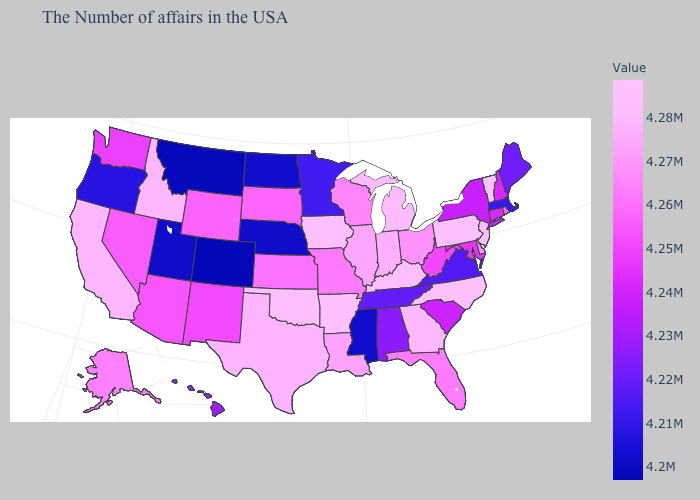Does Arizona have a lower value than Louisiana?
Be succinct. Yes. Does Arizona have a higher value than Alabama?
Keep it brief. Yes. Among the states that border Idaho , does Wyoming have the highest value?
Short answer required. Yes. Which states hav the highest value in the MidWest?
Short answer required. Iowa. Which states have the lowest value in the USA?
Be succinct. Colorado. Does the map have missing data?
Concise answer only. No. Does New Mexico have the highest value in the USA?
Concise answer only. No. Does Connecticut have the highest value in the Northeast?
Keep it brief. No. 